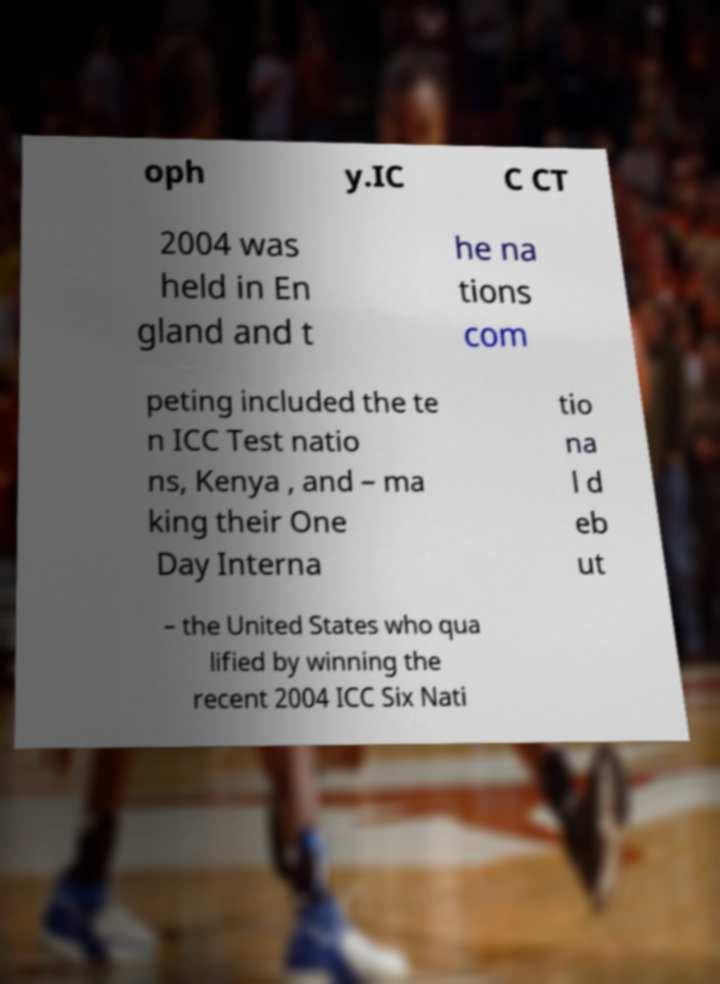What messages or text are displayed in this image? I need them in a readable, typed format. oph y.IC C CT 2004 was held in En gland and t he na tions com peting included the te n ICC Test natio ns, Kenya , and – ma king their One Day Interna tio na l d eb ut – the United States who qua lified by winning the recent 2004 ICC Six Nati 